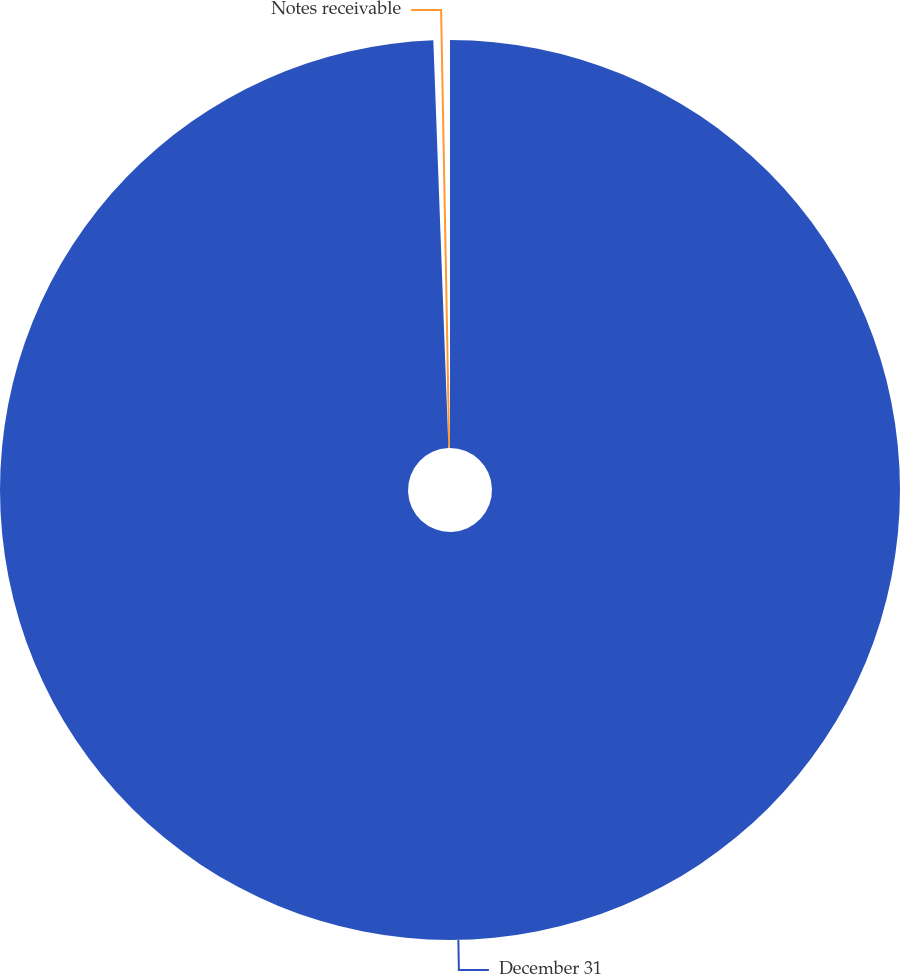Convert chart to OTSL. <chart><loc_0><loc_0><loc_500><loc_500><pie_chart><fcel>December 31<fcel>Notes receivable<nl><fcel>99.41%<fcel>0.59%<nl></chart> 